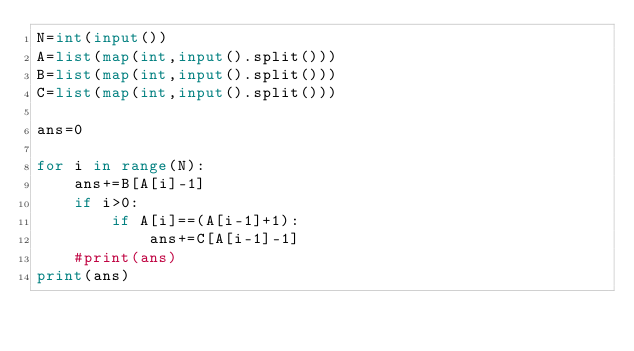Convert code to text. <code><loc_0><loc_0><loc_500><loc_500><_Python_>N=int(input())
A=list(map(int,input().split()))
B=list(map(int,input().split()))
C=list(map(int,input().split()))

ans=0

for i in range(N):
    ans+=B[A[i]-1]
    if i>0:
        if A[i]==(A[i-1]+1):
            ans+=C[A[i-1]-1]
    #print(ans)
print(ans)</code> 